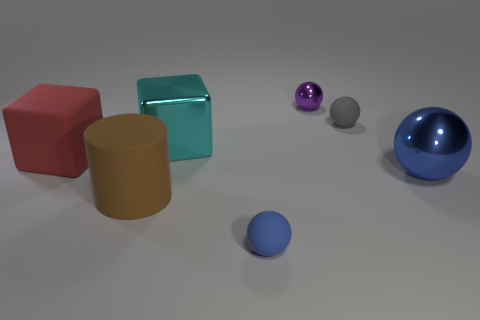Can you describe the arrangement of all the colored objects? Certainly! The image displays six objects on a flat surface: on the left, there's a red cube and a tan cylinder close to each other; in the middle, a teal cube; and on the right, three spheres in a line — a purple one, a gray one, and at the far right, a large blue sphere. A small blue sphere is positioned in the foreground. 